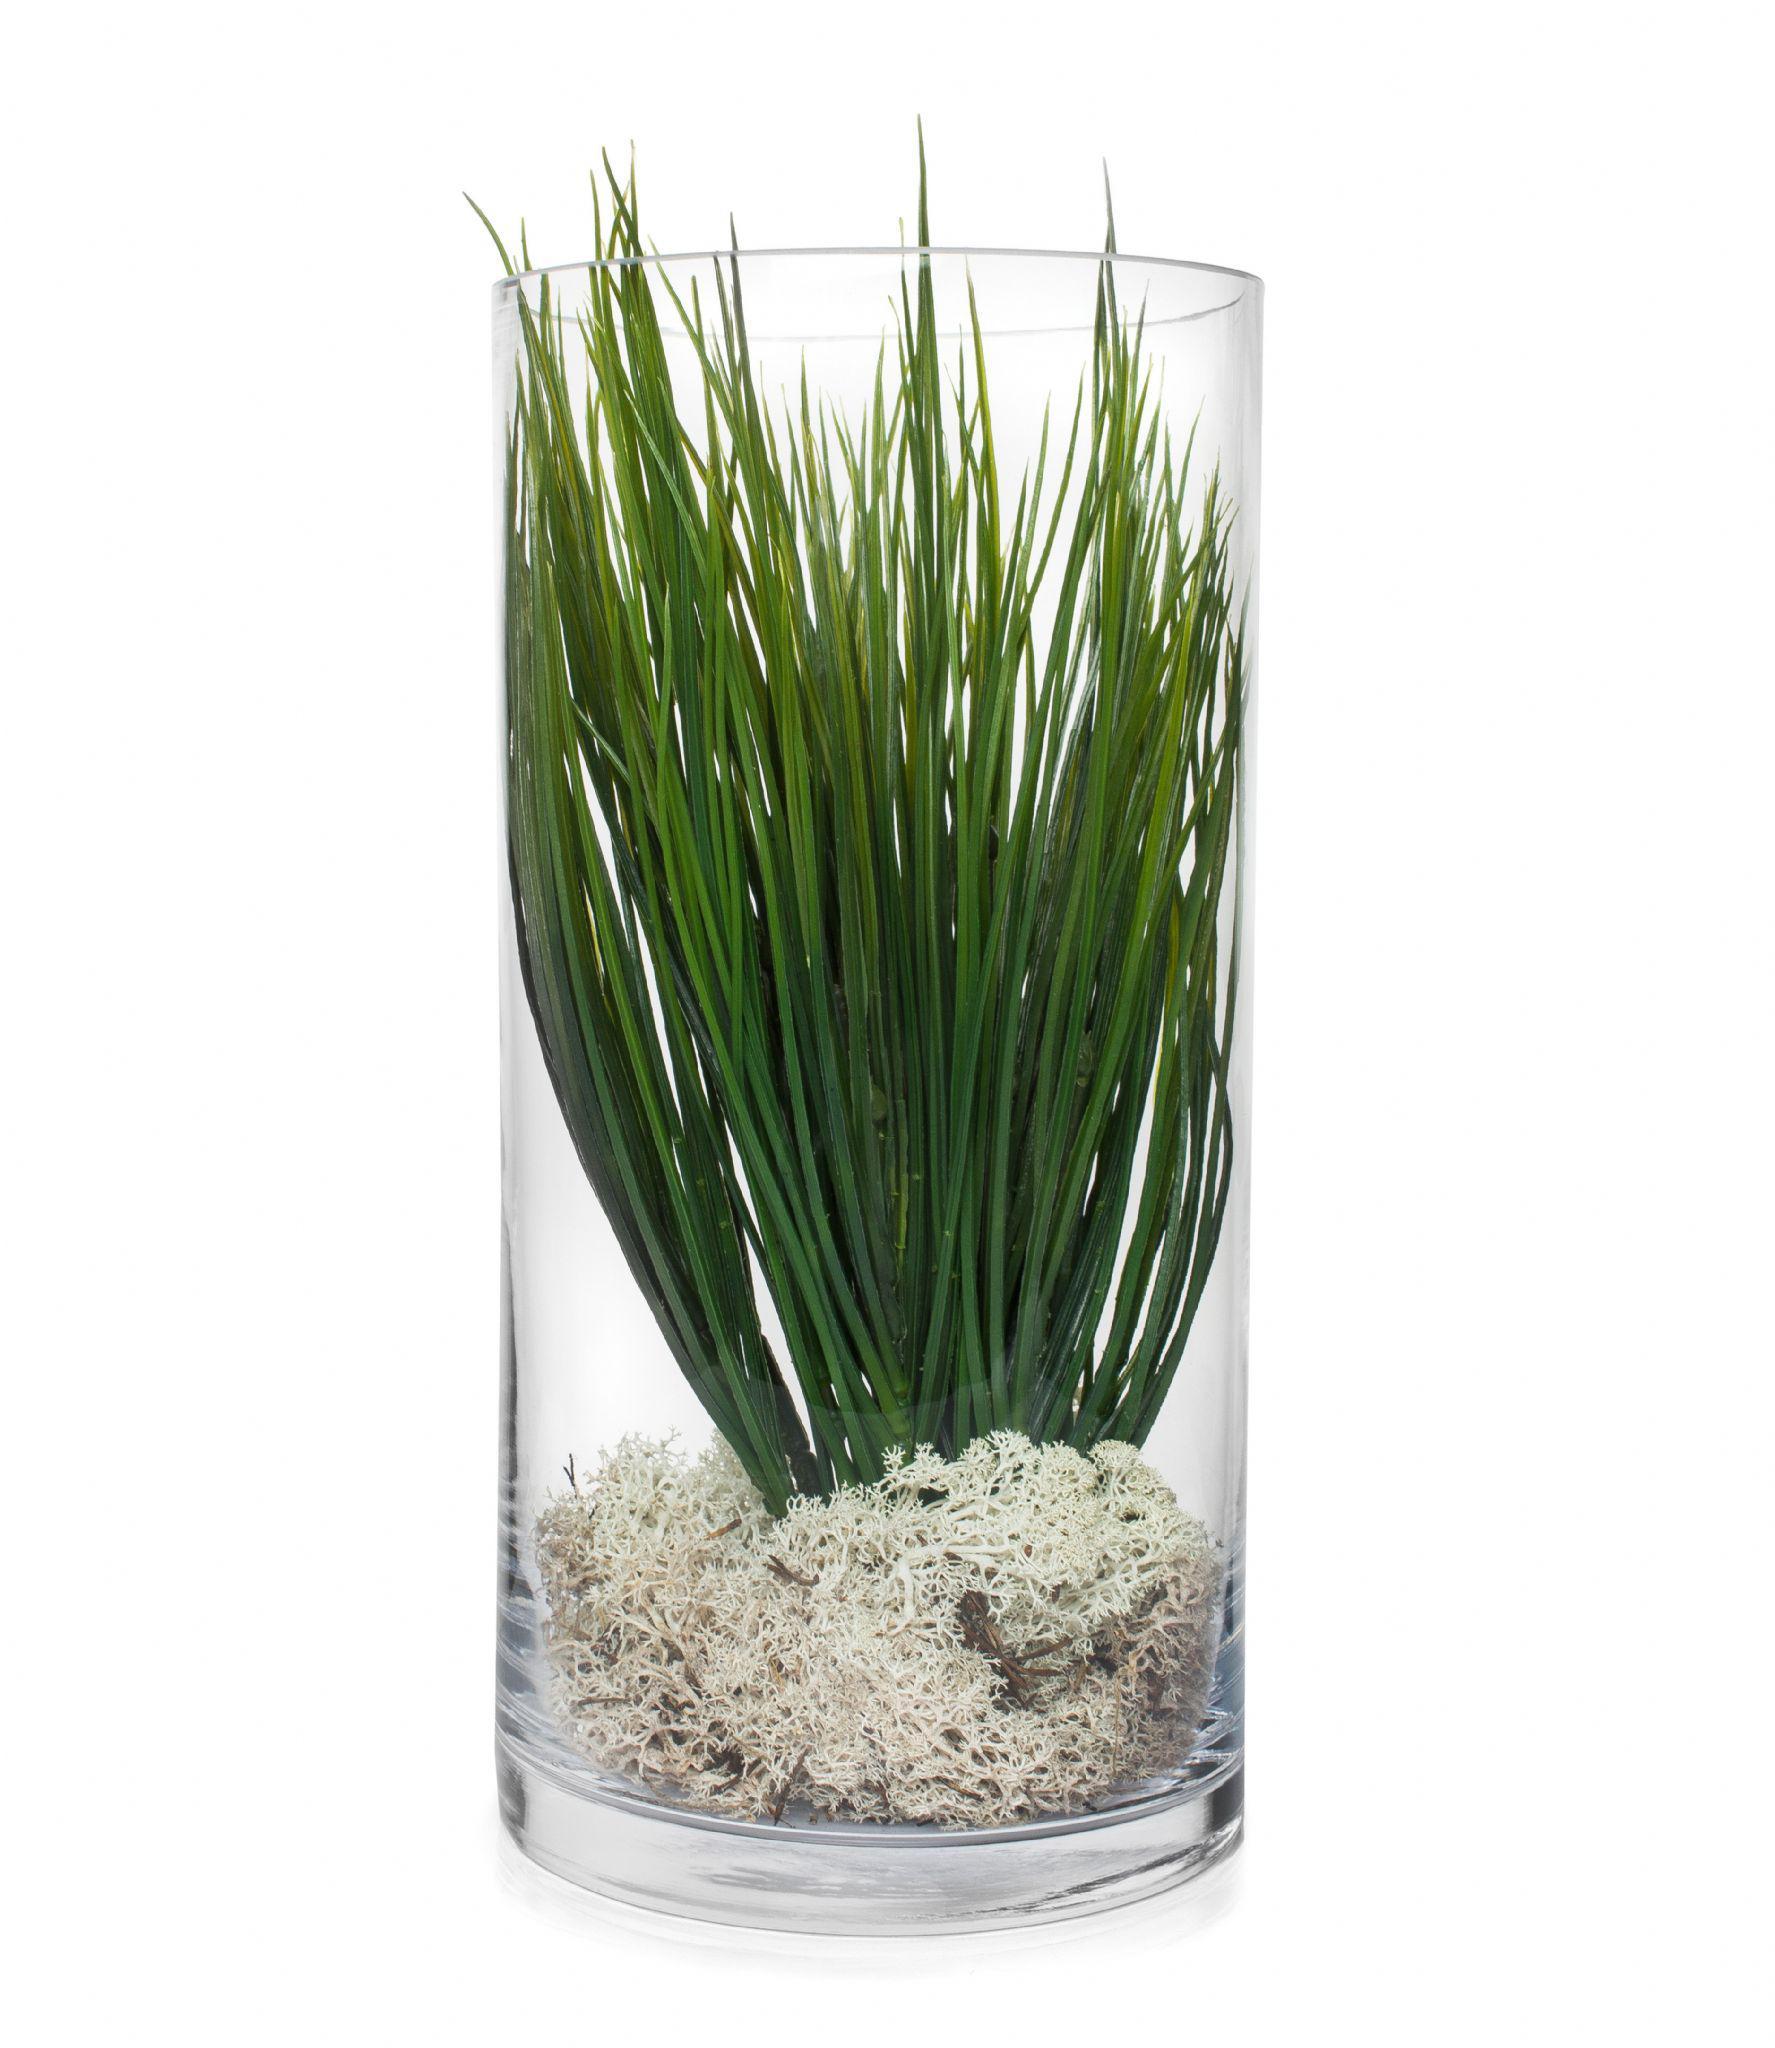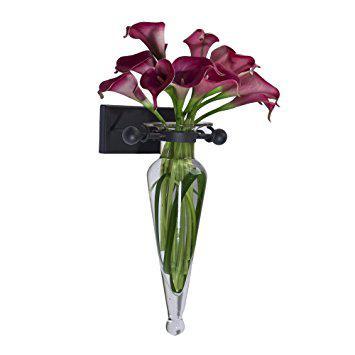The first image is the image on the left, the second image is the image on the right. Assess this claim about the two images: "At least one of the flowers is a rose.". Correct or not? Answer yes or no. No. The first image is the image on the left, the second image is the image on the right. Analyze the images presented: Is the assertion "An image shows a vase containing at least one white tulip." valid? Answer yes or no. No. 